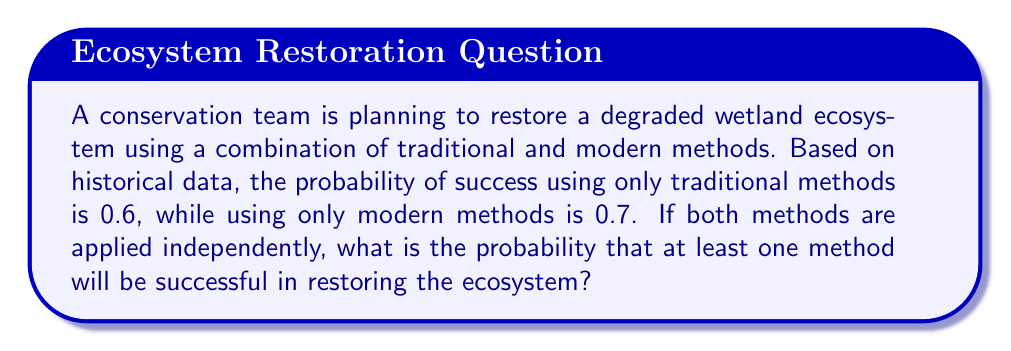Teach me how to tackle this problem. Let's approach this step-by-step:

1) Let A be the event that traditional methods are successful, and B be the event that modern methods are successful.

2) Given:
   P(A) = 0.6 (probability of success using traditional methods)
   P(B) = 0.7 (probability of success using modern methods)

3) We want to find the probability that at least one method is successful. This is equivalent to finding the probability that it's not the case that both methods fail.

4) Probability of both methods failing:
   P(both fail) = P(A' ∩ B') = P(A') × P(B')
   
   Where A' and B' represent the failure of traditional and modern methods respectively.

5) P(A') = 1 - P(A) = 1 - 0.6 = 0.4
   P(B') = 1 - P(B) = 1 - 0.7 = 0.3

6) P(both fail) = 0.4 × 0.3 = 0.12

7) Therefore, the probability of at least one method being successful is:
   P(at least one successful) = 1 - P(both fail) = 1 - 0.12 = 0.88

Thus, there is an 88% chance that at least one method will be successful in restoring the ecosystem.
Answer: 0.88 